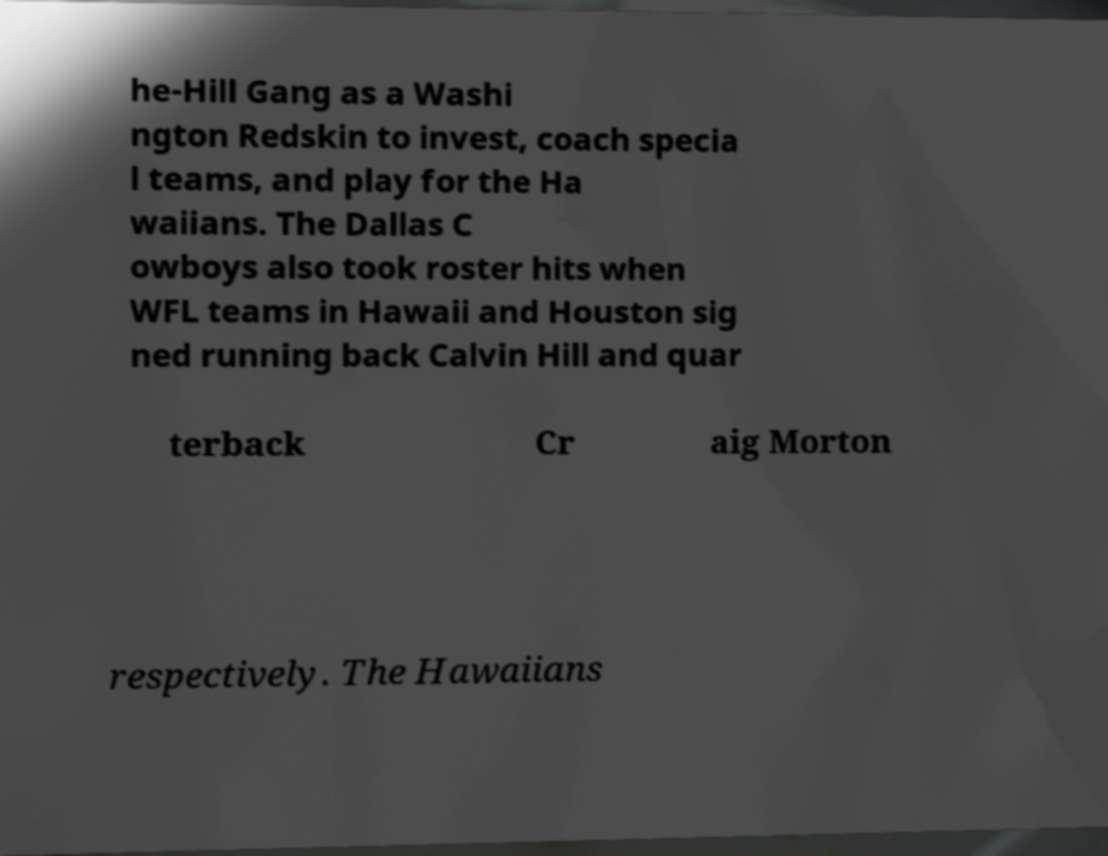Could you assist in decoding the text presented in this image and type it out clearly? he-Hill Gang as a Washi ngton Redskin to invest, coach specia l teams, and play for the Ha waiians. The Dallas C owboys also took roster hits when WFL teams in Hawaii and Houston sig ned running back Calvin Hill and quar terback Cr aig Morton respectively. The Hawaiians 